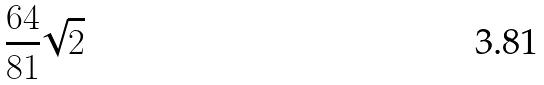<formula> <loc_0><loc_0><loc_500><loc_500>\frac { 6 4 } { 8 1 } \sqrt { 2 }</formula> 